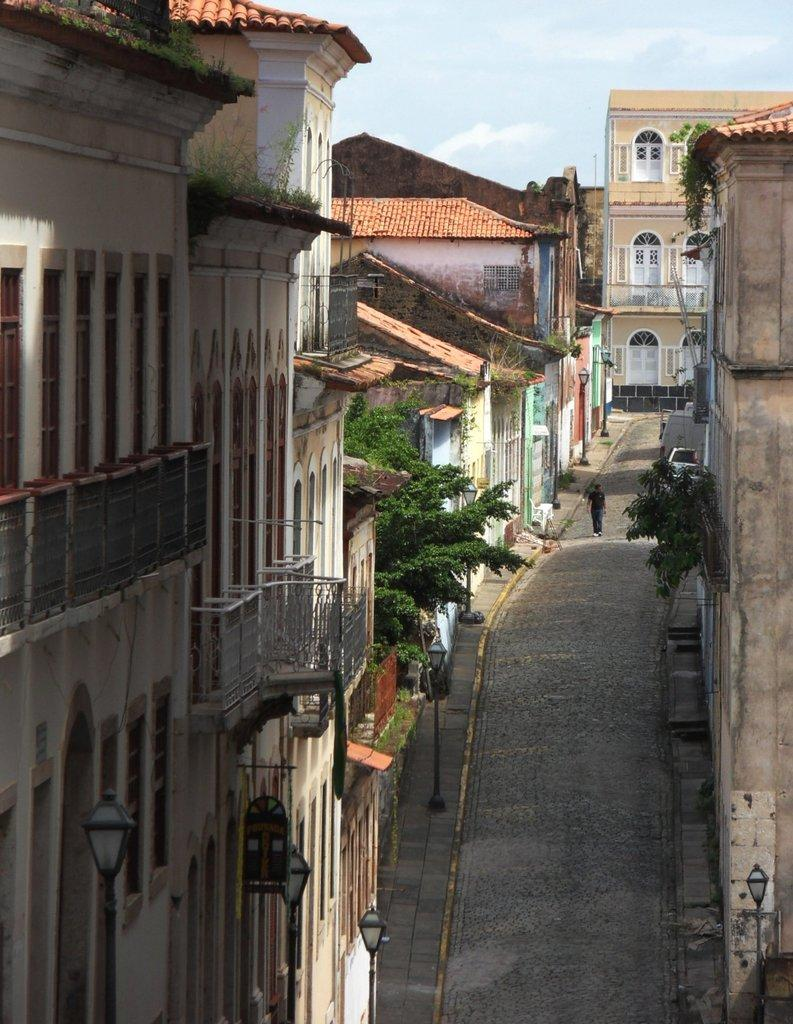What is the main subject in the image? There is a person on the road in the image. What can be seen in the background of the image? The sky is visible in the background of the image. What type of structures are present in the image? There are buildings with windows in the image. What other objects can be seen in the image? There are trees, light poles, and some objects in the image. What type of paste is being used to stick the rings on the person in the image? There are no rings or paste present in the image; it only features a person on the road, trees, light poles, buildings, and other objects. 